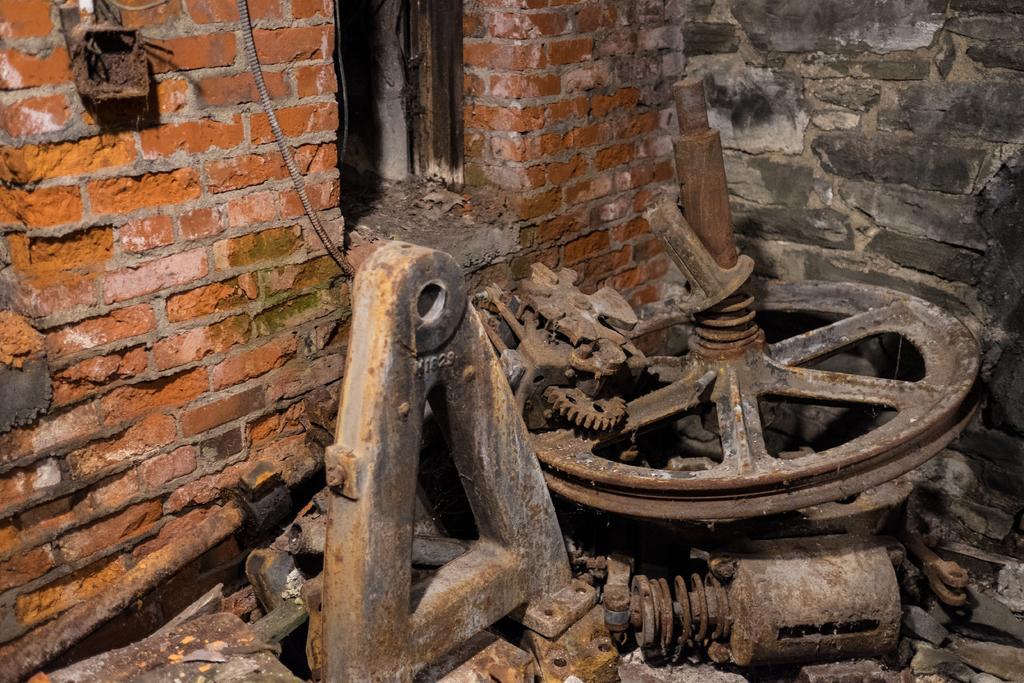In one or two sentences, can you explain what this image depicts? In this image I can see a brick wall. I can see a wheel and few iron objects. 